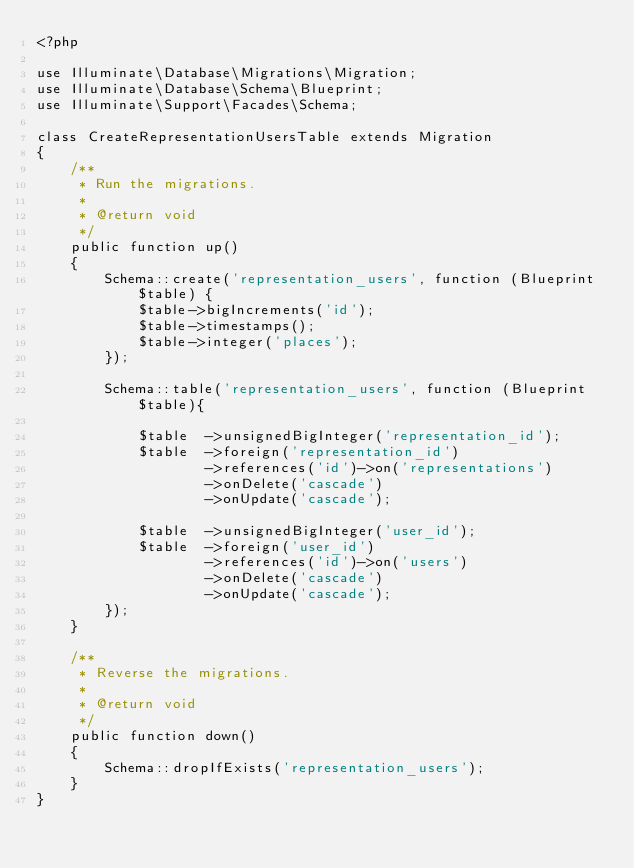Convert code to text. <code><loc_0><loc_0><loc_500><loc_500><_PHP_><?php

use Illuminate\Database\Migrations\Migration;
use Illuminate\Database\Schema\Blueprint;
use Illuminate\Support\Facades\Schema;

class CreateRepresentationUsersTable extends Migration
{
    /**
     * Run the migrations.
     *
     * @return void
     */
    public function up()
    {
        Schema::create('representation_users', function (Blueprint $table) {
            $table->bigIncrements('id');
            $table->timestamps();
            $table->integer('places');
        });

        Schema::table('representation_users', function (Blueprint $table){

            $table  ->unsignedBigInteger('representation_id');
            $table  ->foreign('representation_id')
                    ->references('id')->on('representations')
                    ->onDelete('cascade')
                    ->onUpdate('cascade');

            $table  ->unsignedBigInteger('user_id');
            $table  ->foreign('user_id')
                    ->references('id')->on('users')
                    ->onDelete('cascade')
                    ->onUpdate('cascade');
        });
    }

    /**
     * Reverse the migrations.
     *
     * @return void
     */
    public function down()
    {
        Schema::dropIfExists('representation_users');
    }
}
</code> 